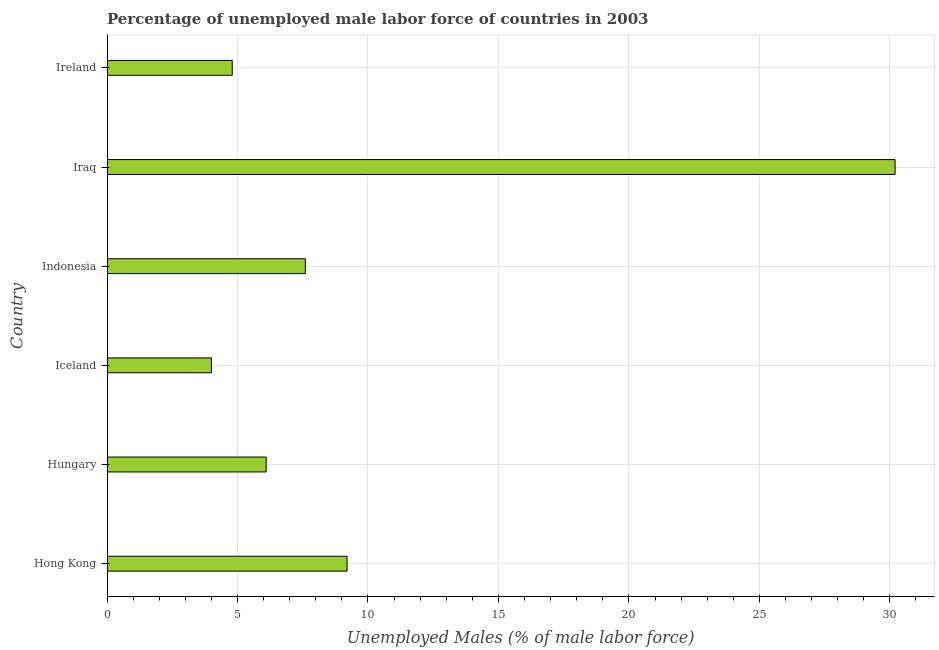Does the graph contain grids?
Your response must be concise. Yes. What is the title of the graph?
Your answer should be compact. Percentage of unemployed male labor force of countries in 2003. What is the label or title of the X-axis?
Provide a short and direct response. Unemployed Males (% of male labor force). What is the label or title of the Y-axis?
Provide a succinct answer. Country. What is the total unemployed male labour force in Ireland?
Your answer should be compact. 4.8. Across all countries, what is the maximum total unemployed male labour force?
Provide a short and direct response. 30.2. In which country was the total unemployed male labour force maximum?
Your answer should be very brief. Iraq. In which country was the total unemployed male labour force minimum?
Your answer should be compact. Iceland. What is the sum of the total unemployed male labour force?
Ensure brevity in your answer.  61.9. What is the difference between the total unemployed male labour force in Iceland and Iraq?
Ensure brevity in your answer.  -26.2. What is the average total unemployed male labour force per country?
Your response must be concise. 10.32. What is the median total unemployed male labour force?
Provide a short and direct response. 6.85. What is the ratio of the total unemployed male labour force in Indonesia to that in Iraq?
Your answer should be very brief. 0.25. What is the difference between the highest and the second highest total unemployed male labour force?
Your answer should be very brief. 21. Is the sum of the total unemployed male labour force in Indonesia and Ireland greater than the maximum total unemployed male labour force across all countries?
Offer a terse response. No. What is the difference between the highest and the lowest total unemployed male labour force?
Give a very brief answer. 26.2. In how many countries, is the total unemployed male labour force greater than the average total unemployed male labour force taken over all countries?
Give a very brief answer. 1. Are all the bars in the graph horizontal?
Make the answer very short. Yes. How many countries are there in the graph?
Make the answer very short. 6. What is the difference between two consecutive major ticks on the X-axis?
Offer a terse response. 5. Are the values on the major ticks of X-axis written in scientific E-notation?
Give a very brief answer. No. What is the Unemployed Males (% of male labor force) in Hong Kong?
Offer a very short reply. 9.2. What is the Unemployed Males (% of male labor force) of Hungary?
Your response must be concise. 6.1. What is the Unemployed Males (% of male labor force) in Iceland?
Keep it short and to the point. 4. What is the Unemployed Males (% of male labor force) of Indonesia?
Your answer should be compact. 7.6. What is the Unemployed Males (% of male labor force) of Iraq?
Offer a very short reply. 30.2. What is the Unemployed Males (% of male labor force) of Ireland?
Offer a very short reply. 4.8. What is the difference between the Unemployed Males (% of male labor force) in Hong Kong and Hungary?
Your answer should be compact. 3.1. What is the difference between the Unemployed Males (% of male labor force) in Hong Kong and Iceland?
Your answer should be very brief. 5.2. What is the difference between the Unemployed Males (% of male labor force) in Hong Kong and Indonesia?
Your answer should be compact. 1.6. What is the difference between the Unemployed Males (% of male labor force) in Hong Kong and Iraq?
Provide a succinct answer. -21. What is the difference between the Unemployed Males (% of male labor force) in Hungary and Iraq?
Your response must be concise. -24.1. What is the difference between the Unemployed Males (% of male labor force) in Iceland and Indonesia?
Offer a very short reply. -3.6. What is the difference between the Unemployed Males (% of male labor force) in Iceland and Iraq?
Keep it short and to the point. -26.2. What is the difference between the Unemployed Males (% of male labor force) in Indonesia and Iraq?
Provide a short and direct response. -22.6. What is the difference between the Unemployed Males (% of male labor force) in Iraq and Ireland?
Your response must be concise. 25.4. What is the ratio of the Unemployed Males (% of male labor force) in Hong Kong to that in Hungary?
Provide a short and direct response. 1.51. What is the ratio of the Unemployed Males (% of male labor force) in Hong Kong to that in Indonesia?
Your answer should be compact. 1.21. What is the ratio of the Unemployed Males (% of male labor force) in Hong Kong to that in Iraq?
Keep it short and to the point. 0.3. What is the ratio of the Unemployed Males (% of male labor force) in Hong Kong to that in Ireland?
Your response must be concise. 1.92. What is the ratio of the Unemployed Males (% of male labor force) in Hungary to that in Iceland?
Offer a very short reply. 1.52. What is the ratio of the Unemployed Males (% of male labor force) in Hungary to that in Indonesia?
Offer a terse response. 0.8. What is the ratio of the Unemployed Males (% of male labor force) in Hungary to that in Iraq?
Ensure brevity in your answer.  0.2. What is the ratio of the Unemployed Males (% of male labor force) in Hungary to that in Ireland?
Give a very brief answer. 1.27. What is the ratio of the Unemployed Males (% of male labor force) in Iceland to that in Indonesia?
Offer a very short reply. 0.53. What is the ratio of the Unemployed Males (% of male labor force) in Iceland to that in Iraq?
Give a very brief answer. 0.13. What is the ratio of the Unemployed Males (% of male labor force) in Iceland to that in Ireland?
Your answer should be very brief. 0.83. What is the ratio of the Unemployed Males (% of male labor force) in Indonesia to that in Iraq?
Ensure brevity in your answer.  0.25. What is the ratio of the Unemployed Males (% of male labor force) in Indonesia to that in Ireland?
Provide a short and direct response. 1.58. What is the ratio of the Unemployed Males (% of male labor force) in Iraq to that in Ireland?
Offer a very short reply. 6.29. 